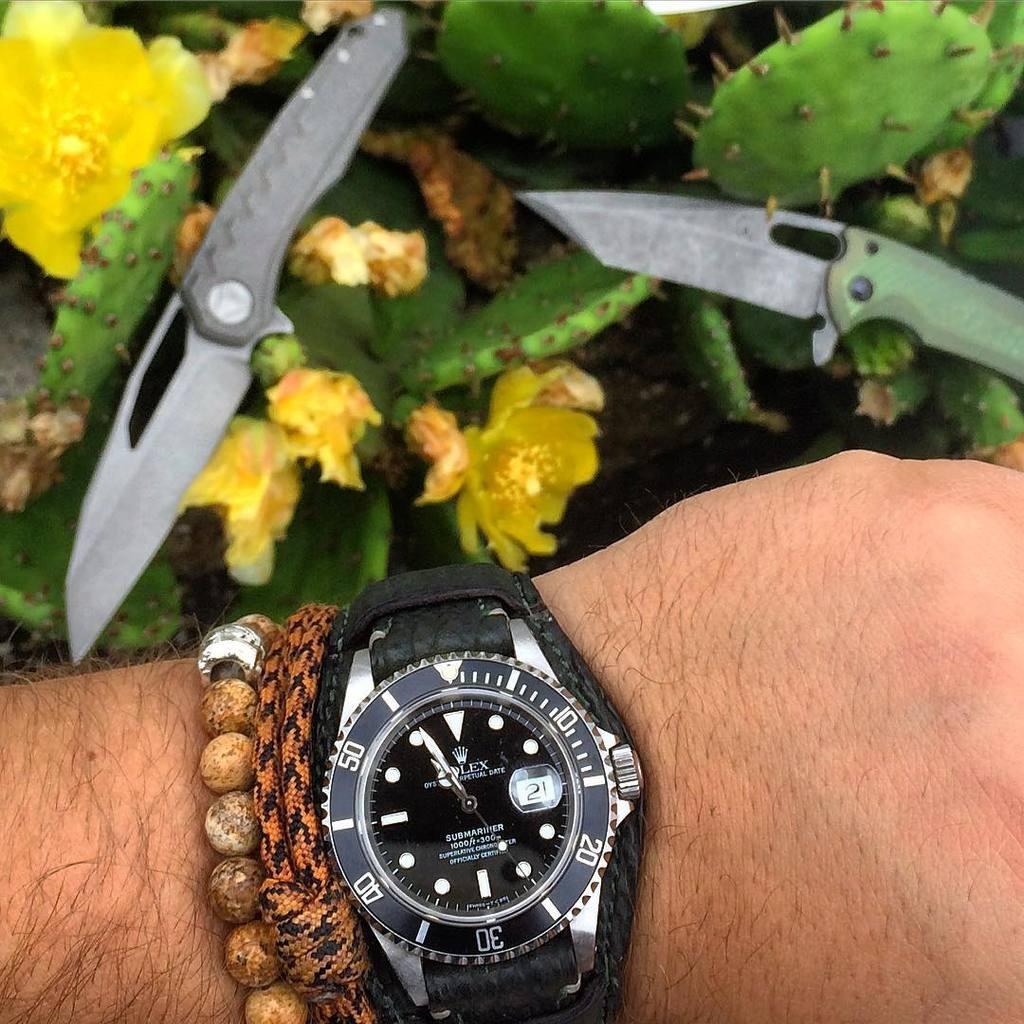<image>
Relay a brief, clear account of the picture shown. A men's Rolex watch that is water resistant up to 1,000 feet. 